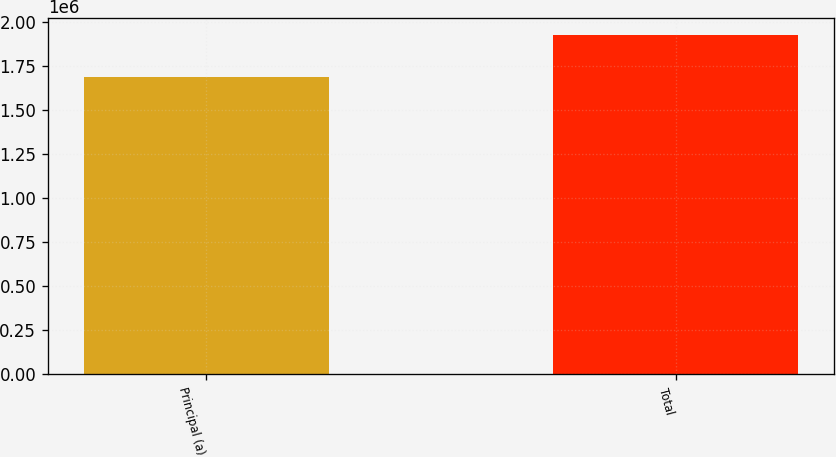<chart> <loc_0><loc_0><loc_500><loc_500><bar_chart><fcel>Principal (a)<fcel>Total<nl><fcel>1.69009e+06<fcel>1.92959e+06<nl></chart> 